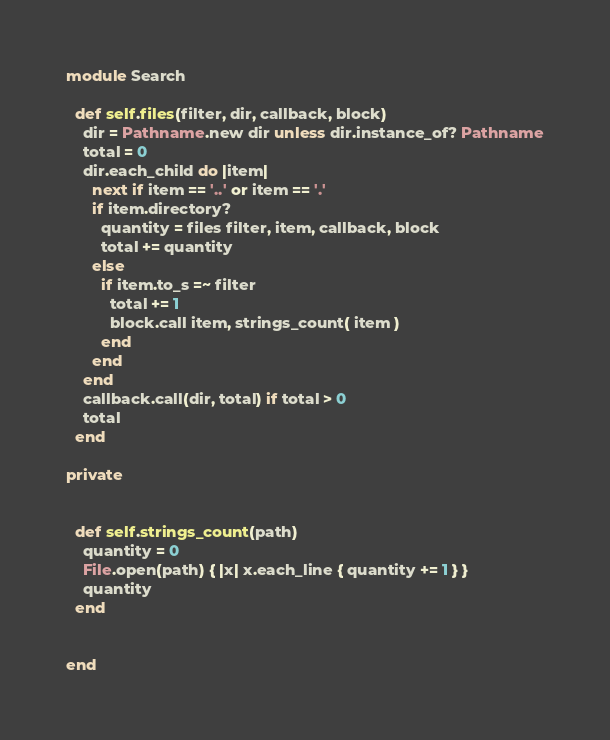Convert code to text. <code><loc_0><loc_0><loc_500><loc_500><_Ruby_>
module Search

  def self.files(filter, dir, callback, block)
    dir = Pathname.new dir unless dir.instance_of? Pathname
    total = 0
    dir.each_child do |item|
      next if item == '..' or item == '.'
      if item.directory?
        quantity = files filter, item, callback, block
        total += quantity
      else
        if item.to_s =~ filter
          total += 1 
          block.call item, strings_count( item )
        end
      end
    end
    callback.call(dir, total) if total > 0
    total
  end

private


  def self.strings_count(path)
    quantity = 0
    File.open(path) { |x| x.each_line { quantity += 1 } }
    quantity
  end


end

</code> 